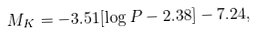Convert formula to latex. <formula><loc_0><loc_0><loc_500><loc_500>M _ { K } = - 3 . 5 1 [ \log P - 2 . 3 8 ] - 7 . 2 4 ,</formula> 